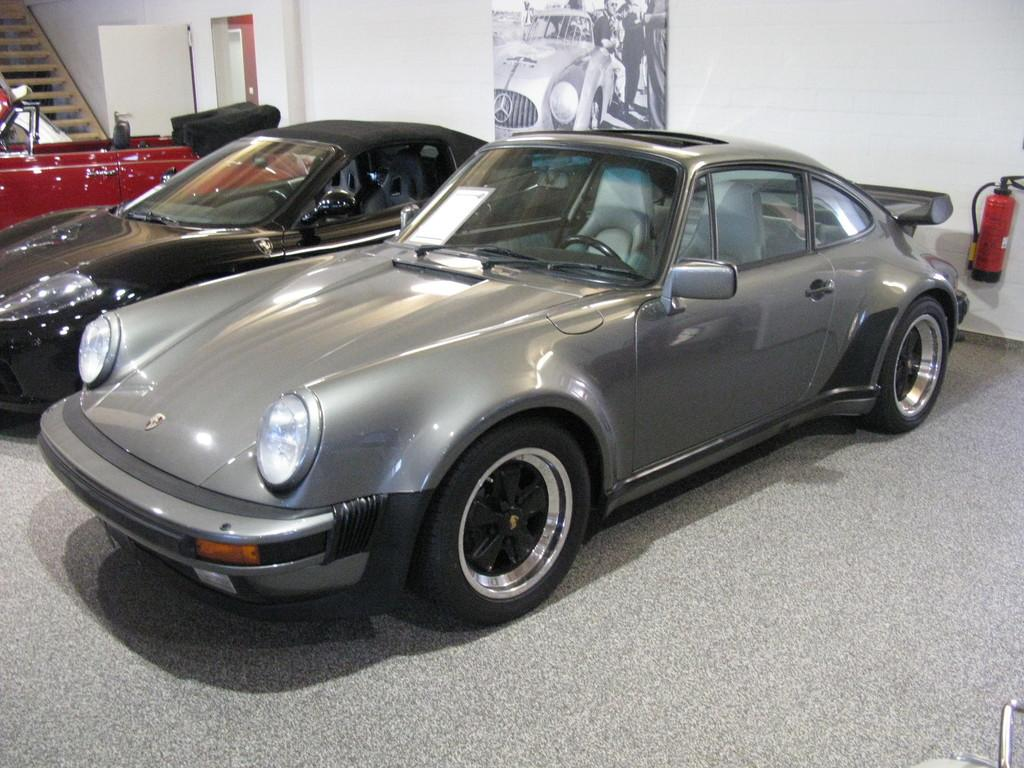What objects are on the floor in the image? There are cars on the floor in the image. What safety device can be seen in the image? A fire extinguisher is visible in the image. What architectural feature is present in the image? There is a door in the image. What can be used to move between different levels in the image? There are steps in the image. What is hanging on the wall in the background of the image? In the background, there is a poster on the wall. What type of book is being read by the muscle in the image? There is no book or muscle present in the image. 